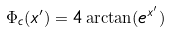<formula> <loc_0><loc_0><loc_500><loc_500>\Phi _ { c } ( x ^ { \prime } ) = 4 \arctan ( e ^ { x ^ { \prime } } )</formula> 